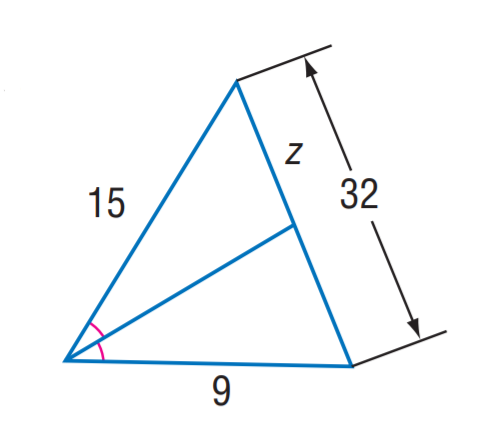Question: Find z.
Choices:
A. 15
B. 18
C. 20
D. 24
Answer with the letter. Answer: C 